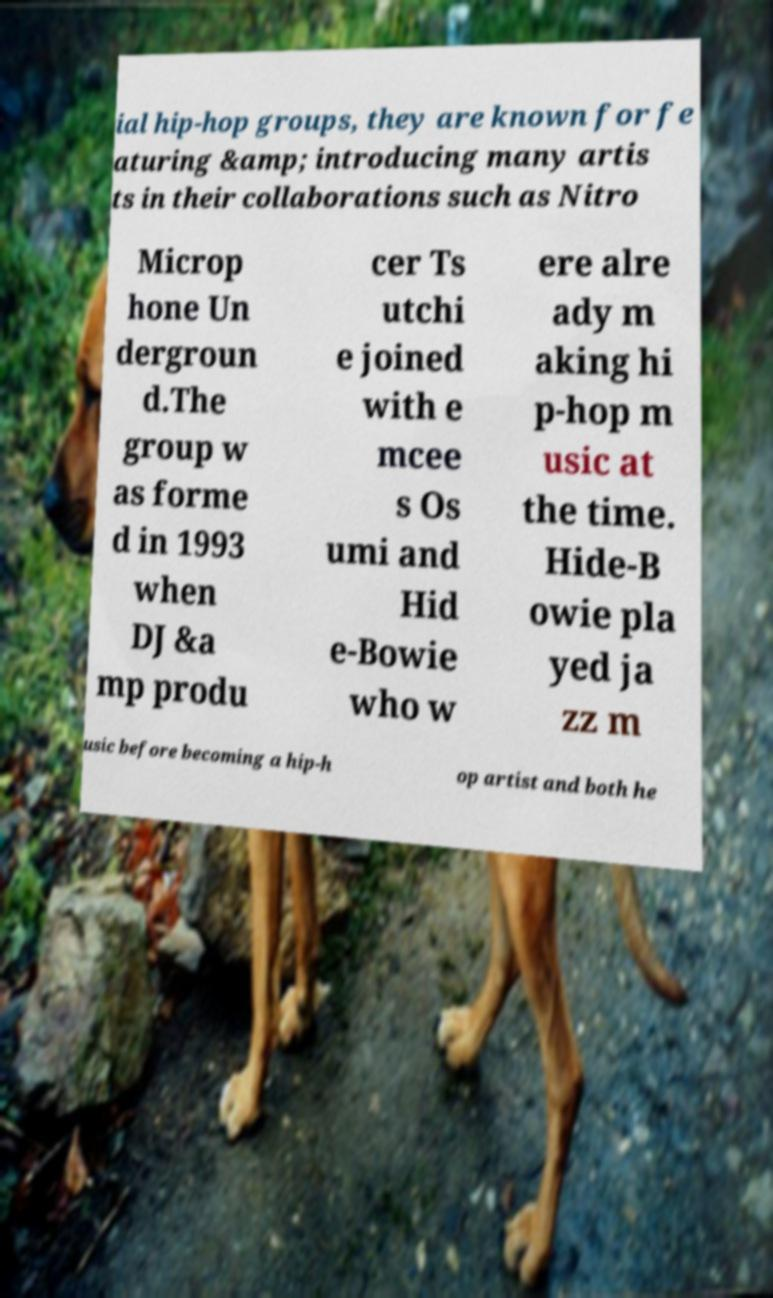Please identify and transcribe the text found in this image. ial hip-hop groups, they are known for fe aturing &amp; introducing many artis ts in their collaborations such as Nitro Microp hone Un dergroun d.The group w as forme d in 1993 when DJ &a mp produ cer Ts utchi e joined with e mcee s Os umi and Hid e-Bowie who w ere alre ady m aking hi p-hop m usic at the time. Hide-B owie pla yed ja zz m usic before becoming a hip-h op artist and both he 